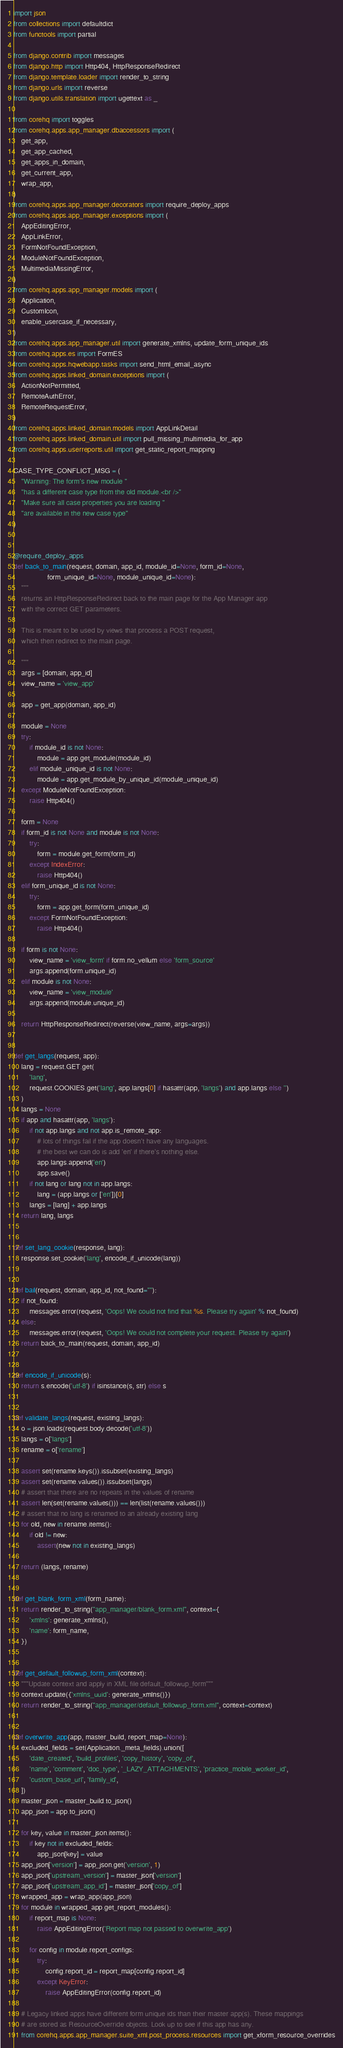Convert code to text. <code><loc_0><loc_0><loc_500><loc_500><_Python_>import json
from collections import defaultdict
from functools import partial

from django.contrib import messages
from django.http import Http404, HttpResponseRedirect
from django.template.loader import render_to_string
from django.urls import reverse
from django.utils.translation import ugettext as _

from corehq import toggles
from corehq.apps.app_manager.dbaccessors import (
    get_app,
    get_app_cached,
    get_apps_in_domain,
    get_current_app,
    wrap_app,
)
from corehq.apps.app_manager.decorators import require_deploy_apps
from corehq.apps.app_manager.exceptions import (
    AppEditingError,
    AppLinkError,
    FormNotFoundException,
    ModuleNotFoundException,
    MultimediaMissingError,
)
from corehq.apps.app_manager.models import (
    Application,
    CustomIcon,
    enable_usercase_if_necessary,
)
from corehq.apps.app_manager.util import generate_xmlns, update_form_unique_ids
from corehq.apps.es import FormES
from corehq.apps.hqwebapp.tasks import send_html_email_async
from corehq.apps.linked_domain.exceptions import (
    ActionNotPermitted,
    RemoteAuthError,
    RemoteRequestError,
)
from corehq.apps.linked_domain.models import AppLinkDetail
from corehq.apps.linked_domain.util import pull_missing_multimedia_for_app
from corehq.apps.userreports.util import get_static_report_mapping

CASE_TYPE_CONFLICT_MSG = (
    "Warning: The form's new module "
    "has a different case type from the old module.<br />"
    "Make sure all case properties you are loading "
    "are available in the new case type"
)


@require_deploy_apps
def back_to_main(request, domain, app_id, module_id=None, form_id=None,
                 form_unique_id=None, module_unique_id=None):
    """
    returns an HttpResponseRedirect back to the main page for the App Manager app
    with the correct GET parameters.

    This is meant to be used by views that process a POST request,
    which then redirect to the main page.

    """
    args = [domain, app_id]
    view_name = 'view_app'

    app = get_app(domain, app_id)

    module = None
    try:
        if module_id is not None:
            module = app.get_module(module_id)
        elif module_unique_id is not None:
            module = app.get_module_by_unique_id(module_unique_id)
    except ModuleNotFoundException:
        raise Http404()

    form = None
    if form_id is not None and module is not None:
        try:
            form = module.get_form(form_id)
        except IndexError:
            raise Http404()
    elif form_unique_id is not None:
        try:
            form = app.get_form(form_unique_id)
        except FormNotFoundException:
            raise Http404()

    if form is not None:
        view_name = 'view_form' if form.no_vellum else 'form_source'
        args.append(form.unique_id)
    elif module is not None:
        view_name = 'view_module'
        args.append(module.unique_id)

    return HttpResponseRedirect(reverse(view_name, args=args))


def get_langs(request, app):
    lang = request.GET.get(
        'lang',
        request.COOKIES.get('lang', app.langs[0] if hasattr(app, 'langs') and app.langs else '')
    )
    langs = None
    if app and hasattr(app, 'langs'):
        if not app.langs and not app.is_remote_app:
            # lots of things fail if the app doesn't have any languages.
            # the best we can do is add 'en' if there's nothing else.
            app.langs.append('en')
            app.save()
        if not lang or lang not in app.langs:
            lang = (app.langs or ['en'])[0]
        langs = [lang] + app.langs
    return lang, langs


def set_lang_cookie(response, lang):
    response.set_cookie('lang', encode_if_unicode(lang))


def bail(request, domain, app_id, not_found=""):
    if not_found:
        messages.error(request, 'Oops! We could not find that %s. Please try again' % not_found)
    else:
        messages.error(request, 'Oops! We could not complete your request. Please try again')
    return back_to_main(request, domain, app_id)


def encode_if_unicode(s):
    return s.encode('utf-8') if isinstance(s, str) else s


def validate_langs(request, existing_langs):
    o = json.loads(request.body.decode('utf-8'))
    langs = o['langs']
    rename = o['rename']

    assert set(rename.keys()).issubset(existing_langs)
    assert set(rename.values()).issubset(langs)
    # assert that there are no repeats in the values of rename
    assert len(set(rename.values())) == len(list(rename.values()))
    # assert that no lang is renamed to an already existing lang
    for old, new in rename.items():
        if old != new:
            assert(new not in existing_langs)

    return (langs, rename)


def get_blank_form_xml(form_name):
    return render_to_string("app_manager/blank_form.xml", context={
        'xmlns': generate_xmlns(),
        'name': form_name,
    })


def get_default_followup_form_xml(context):
    """Update context and apply in XML file default_followup_form"""
    context.update({'xmlns_uuid': generate_xmlns()})
    return render_to_string("app_manager/default_followup_form.xml", context=context)


def overwrite_app(app, master_build, report_map=None):
    excluded_fields = set(Application._meta_fields).union([
        'date_created', 'build_profiles', 'copy_history', 'copy_of',
        'name', 'comment', 'doc_type', '_LAZY_ATTACHMENTS', 'practice_mobile_worker_id',
        'custom_base_url', 'family_id',
    ])
    master_json = master_build.to_json()
    app_json = app.to_json()

    for key, value in master_json.items():
        if key not in excluded_fields:
            app_json[key] = value
    app_json['version'] = app_json.get('version', 1)
    app_json['upstream_version'] = master_json['version']
    app_json['upstream_app_id'] = master_json['copy_of']
    wrapped_app = wrap_app(app_json)
    for module in wrapped_app.get_report_modules():
        if report_map is None:
            raise AppEditingError('Report map not passed to overwrite_app')

        for config in module.report_configs:
            try:
                config.report_id = report_map[config.report_id]
            except KeyError:
                raise AppEditingError(config.report_id)

    # Legacy linked apps have different form unique ids than their master app(s). These mappings
    # are stored as ResourceOverride objects. Look up to see if this app has any.
    from corehq.apps.app_manager.suite_xml.post_process.resources import get_xform_resource_overrides</code> 